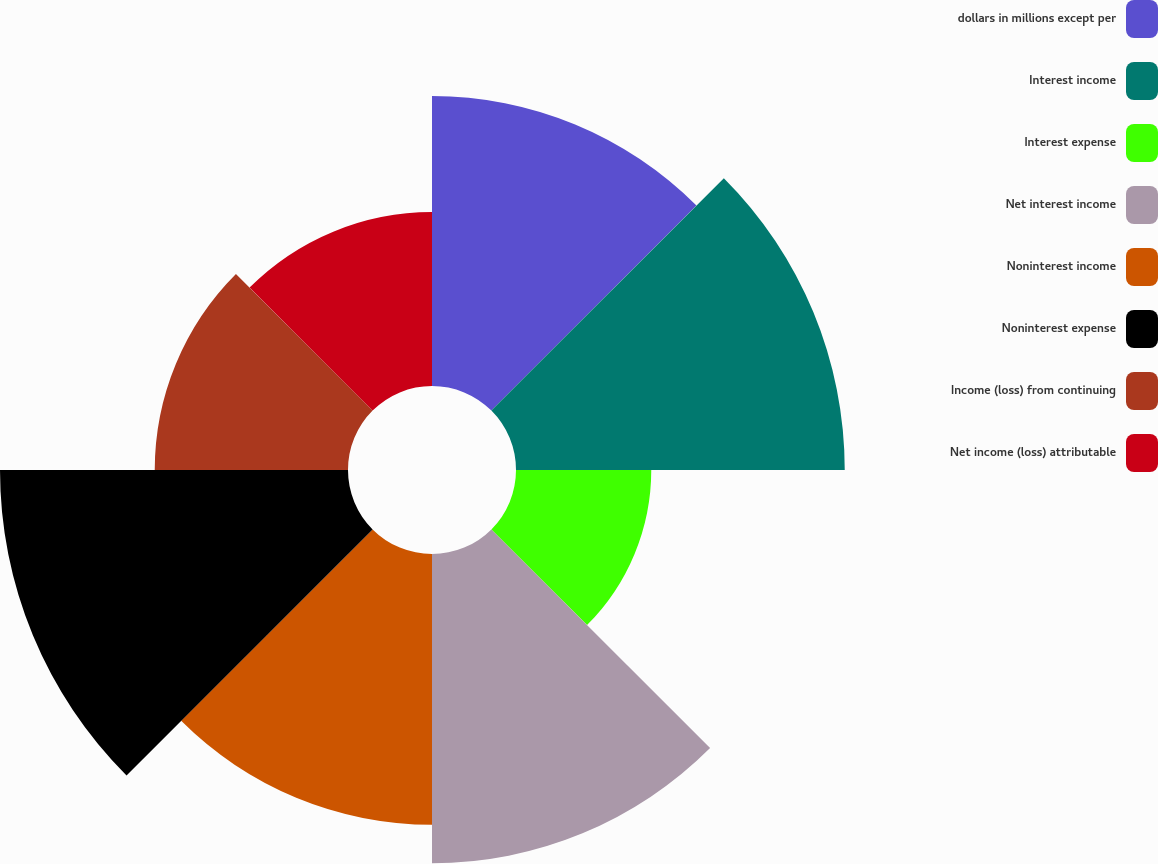<chart> <loc_0><loc_0><loc_500><loc_500><pie_chart><fcel>dollars in millions except per<fcel>Interest income<fcel>Interest expense<fcel>Net interest income<fcel>Noninterest income<fcel>Noninterest expense<fcel>Income (loss) from continuing<fcel>Net income (loss) attributable<nl><fcel>14.15%<fcel>16.04%<fcel>6.6%<fcel>15.09%<fcel>13.21%<fcel>16.98%<fcel>9.43%<fcel>8.49%<nl></chart> 